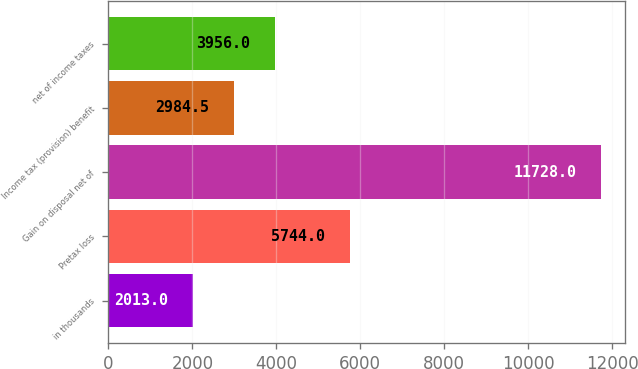<chart> <loc_0><loc_0><loc_500><loc_500><bar_chart><fcel>in thousands<fcel>Pretax loss<fcel>Gain on disposal net of<fcel>Income tax (provision) benefit<fcel>net of income taxes<nl><fcel>2013<fcel>5744<fcel>11728<fcel>2984.5<fcel>3956<nl></chart> 